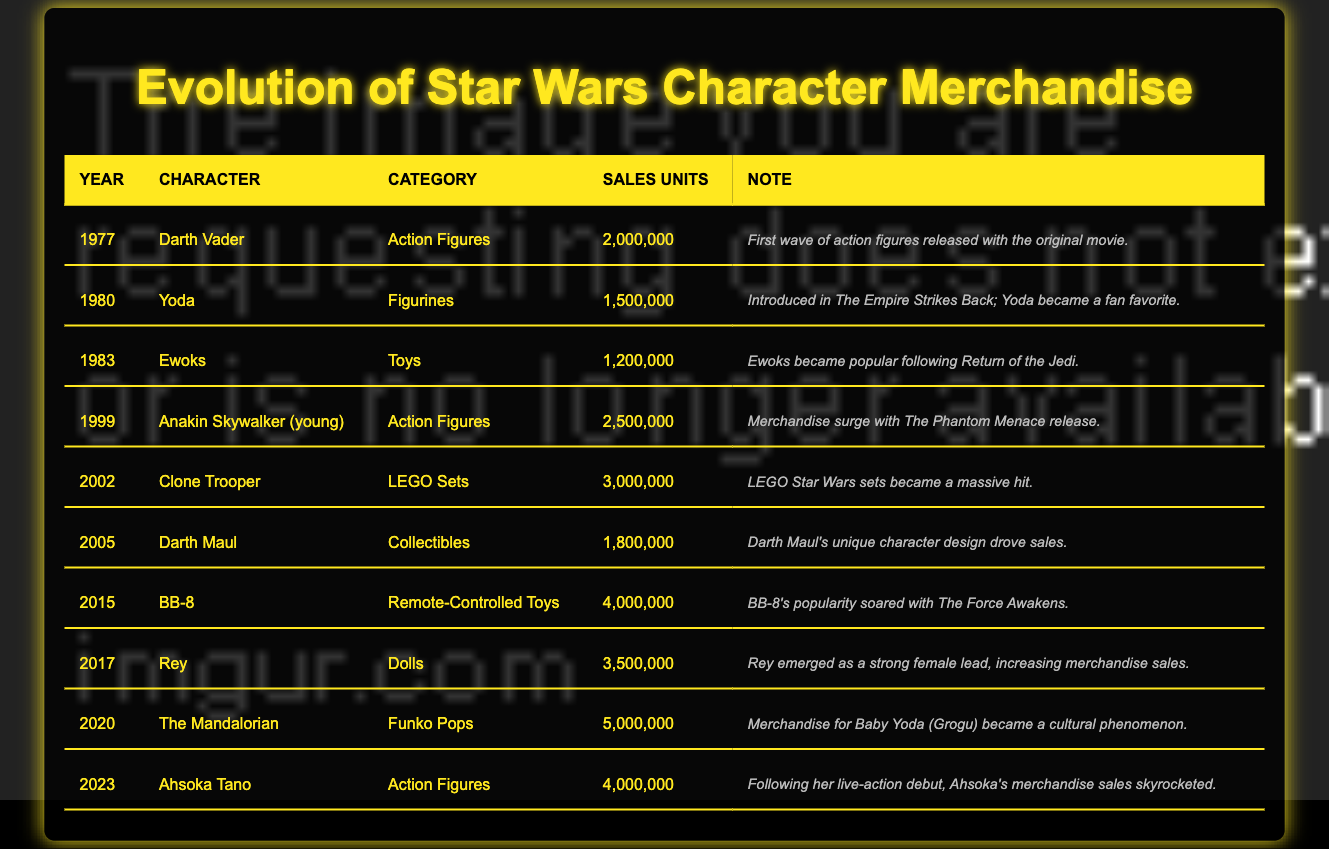What year did Darth Vader merchandise sell the highest units? The highest sales units for Darth Vader were in 1977 with 2,000,000 units sold, which is the only entry for him in the table, hence it is the highest.
Answer: 1977 Which character had the lowest sales units in the table? The character with the lowest sales units is the Ewoks, with only 1,200,000 units sold in 1983.
Answer: Ewoks In which year did merchandise for The Mandalorian achieve the highest sales? The Mandalorian achieved the highest sales in 2020, with 5,000,000 units sold, according to the table.
Answer: 2020 What is the total sales units for action figures across all years listed? The action figures listed are for Darth Vader (2,000,000), Anakin Skywalker (2,500,000), and Ahsoka Tano (4,000,000). Adding these together gives: 2,000,000 + 2,500,000 + 4,000,000 = 8,500,000.
Answer: 8,500,000 Did the sales of BB-8 exceed those of Rey? Yes, BB-8 sold 4,000,000 units in 2015, which is greater than Rey's 3,500,000 units sold in 2017.
Answer: Yes What character's merchandise surpassed 4,000,000 sales units? There are three characters whose merchandise surpassed 4,000,000 sales units: BB-8 (4,000,000), The Mandalorian (5,000,000), and Ahsoka Tano (4,000,000).
Answer: BB-8, The Mandalorian, Ahsoka Tano How did the sales of Anakin Skywalker compare to those of Clone Trooper? Anakin Skywalker sold 2,500,000 units in 1999, while Clone Trooper sold 3,000,000 units in 2002. Therefore, Clone Trooper had higher sales than Anakin.
Answer: Clone Trooper sold more In what category did Yoda achieve 1,500,000 sales, and how did it compare with Ewoks? Yoda achieved 1,500,000 sales in the category of Figurines, and compared to Ewoks, which sold 1,200,000, Yoda's sales were higher by 300,000 units.
Answer: Yoda's sales were higher by 300,000 units If we consider merchandise release years, which character's merchandise was released before 2000 had the maximum sales? The maximum sales before 2000 were by Darth Vader in 1977 with 2,000,000 units sold. Other characters prior to 2000 had lesser sales.
Answer: Darth Vader What character showed the highest increase in merchandise popularity from their initial year to their peak? The Mandalorian showed the highest increase from previous popular characters; its sales reached 5,000,000 in 2020, greatly surpassing previous characters, but considering the other entries, BB-8 had the higher increase compared to its 4,000,000.
Answer: BB-8 